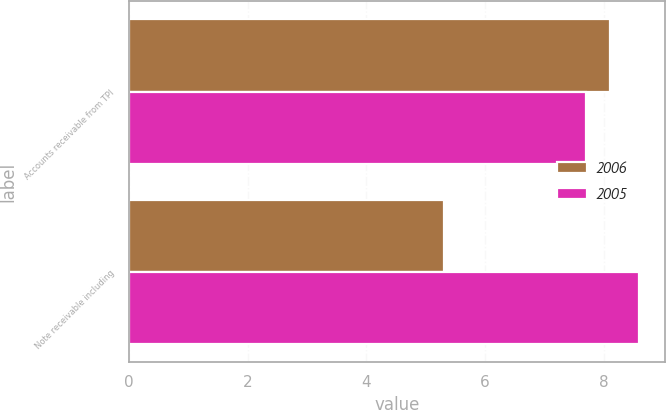<chart> <loc_0><loc_0><loc_500><loc_500><stacked_bar_chart><ecel><fcel>Accounts receivable from TPI<fcel>Note receivable including<nl><fcel>2006<fcel>8.1<fcel>5.3<nl><fcel>2005<fcel>7.7<fcel>8.6<nl></chart> 